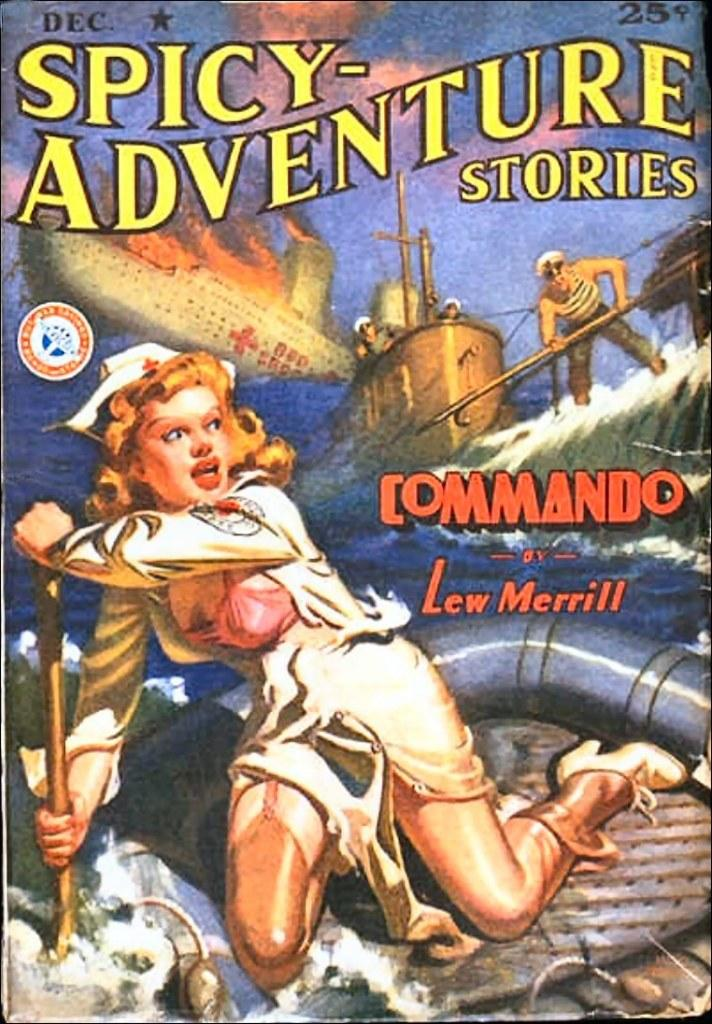<image>
Create a compact narrative representing the image presented. A comic book of "Spicy Adventure Stories" has a woman in a nurses outfit on the cover. 